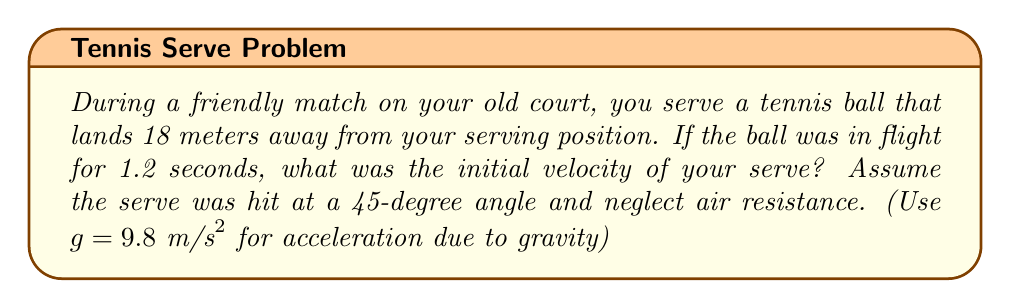Show me your answer to this math problem. To solve this inverse problem, we'll use the equations of motion for projectile motion:

1) First, recall the equations for horizontal and vertical displacement:
   $$x = v_0 \cos(\theta) t$$
   $$y = v_0 \sin(\theta) t - \frac{1}{2}gt^2$$

2) We know:
   - $x = 18 \text{ m}$ (horizontal distance)
   - $t = 1.2 \text{ s}$ (flight time)
   - $\theta = 45°$ (angle of serve)
   - $y = 0$ (ball lands at same height as serve)

3) Using the horizontal displacement equation:
   $$18 = v_0 \cos(45°) \cdot 1.2$$

4) Simplify:
   $$18 = v_0 \cdot \frac{\sqrt{2}}{2} \cdot 1.2$$

5) Solve for $v_0$:
   $$v_0 = \frac{18}{\frac{\sqrt{2}}{2} \cdot 1.2} = 21.21 \text{ m/s}$$

6) Verify using the vertical displacement equation:
   $$0 = v_0 \sin(45°) \cdot 1.2 - \frac{1}{2} \cdot 9.8 \cdot 1.2^2$$
   $$0 = 21.21 \cdot \frac{\sqrt{2}}{2} \cdot 1.2 - \frac{1}{2} \cdot 9.8 \cdot 1.2^2$$
   $$0 = 18 - 7.056$$ (approximately true, small discrepancy due to rounding)

Therefore, the initial velocity of the serve was approximately 21.21 m/s.
Answer: $21.21 \text{ m/s}$ 